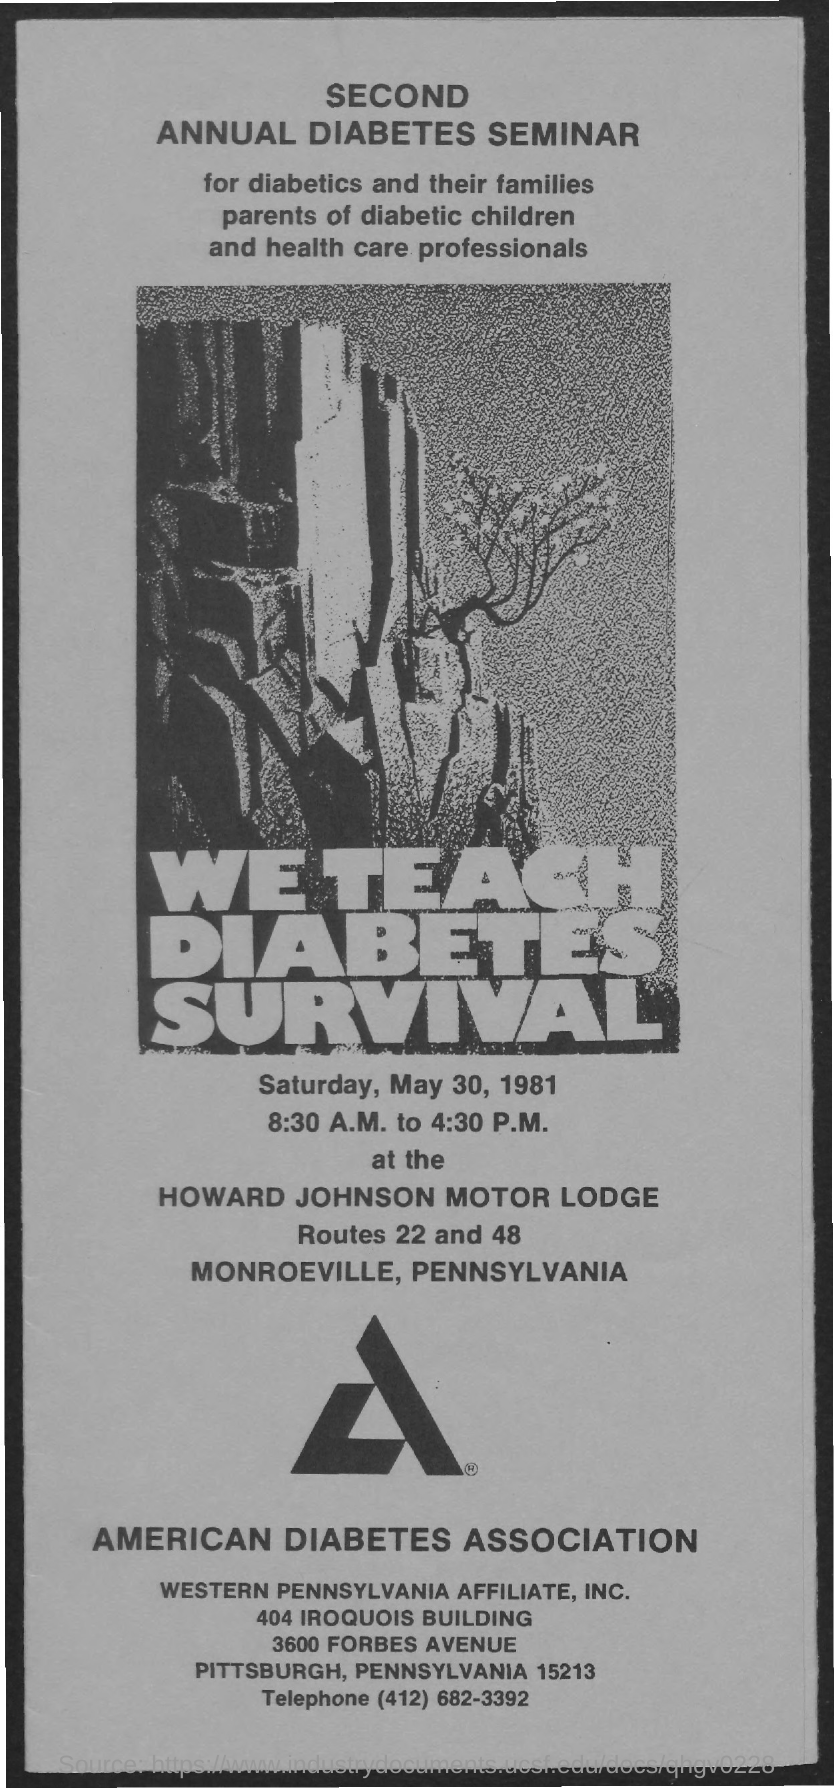Outline some significant characteristics in this image. The seminar will take place on Saturday, May 30, 1981. 